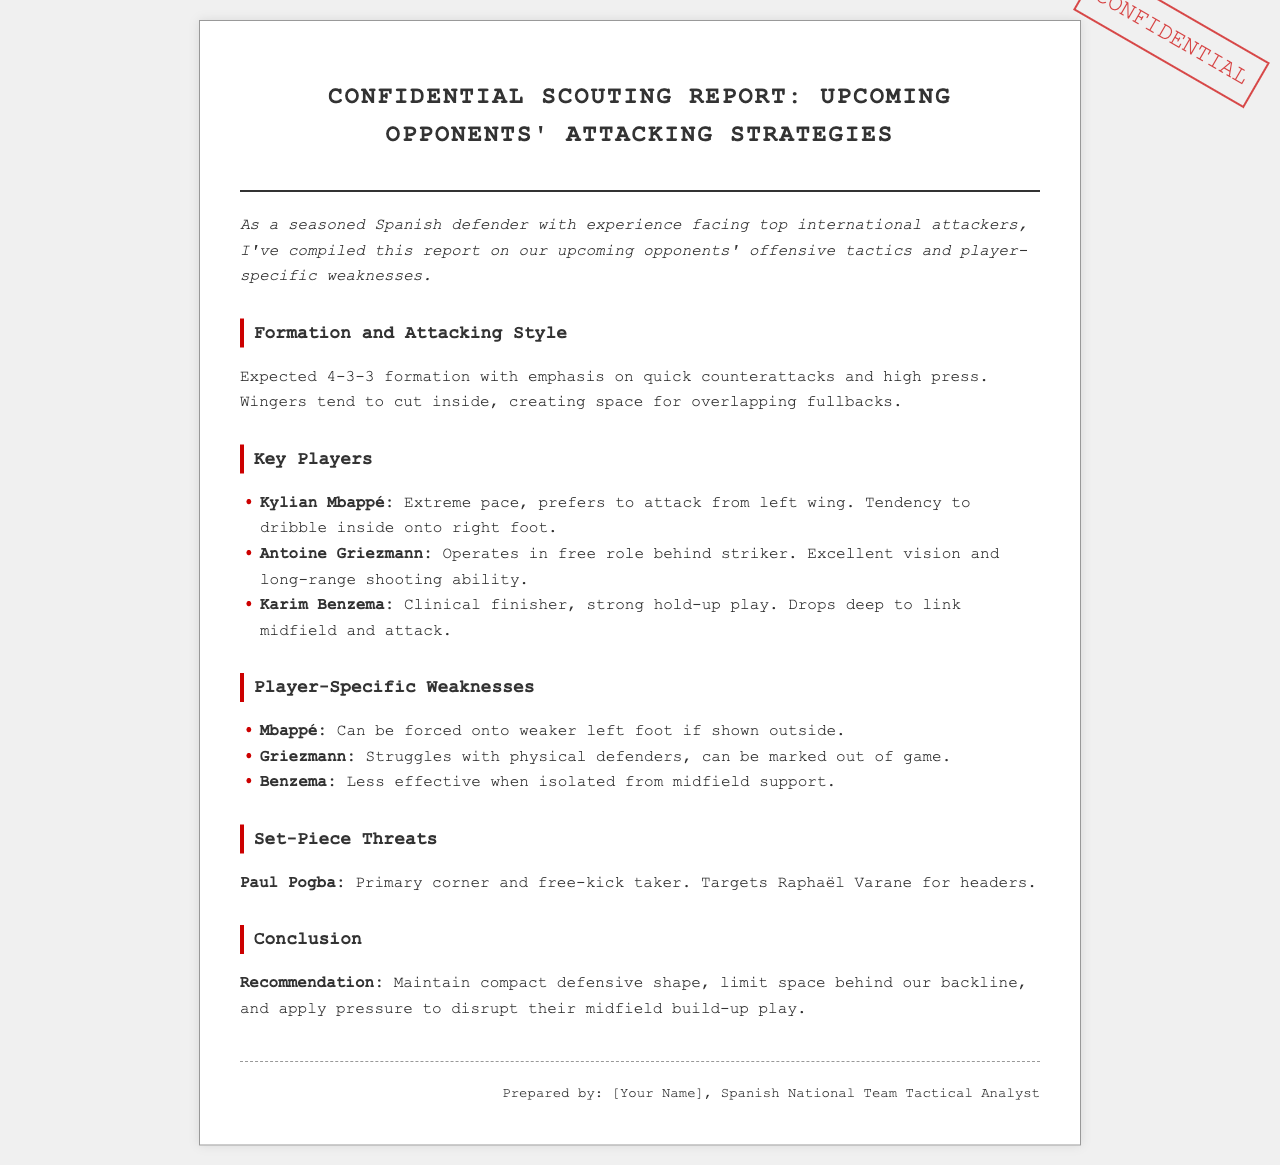What is the expected formation of the opponents? The expected formation is mentioned in the document as a 4-3-3 formation.
Answer: 4-3-3 Who is the primary corner and free-kick taker? The document states that Paul Pogba is the primary corner and free-kick taker.
Answer: Paul Pogba Which player is noted for a strong hold-up play? The document identifies Karim Benzema as having strong hold-up play.
Answer: Karim Benzema What is Kylian Mbappé's tendency when attacking? According to the report, Kylian Mbappé prefers to attack from the left wing.
Answer: Left wing What recommendation is made regarding the defensive shape? The recommendation advises maintaining a compact defensive shape.
Answer: Compact defensive shape What type of defenders does Antoine Griezmann struggle against? The document indicates that Antoine Griezmann struggles with physical defenders.
Answer: Physical defenders Which player drops deep to link midfield and attack? Karim Benzema is the player noted for dropping deep to link midfield and attack.
Answer: Karim Benzema What is the conclusion regarding applying pressure? The conclusion suggests applying pressure to disrupt their midfield build-up play.
Answer: Disrupt midfield build-up play 